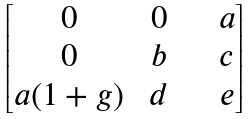<formula> <loc_0><loc_0><loc_500><loc_500>\begin{bmatrix} 0 & \ 0 & \quad a \\ 0 & \ b & \quad c \\ a ( 1 + g ) & \ d & \quad e \end{bmatrix}</formula> 